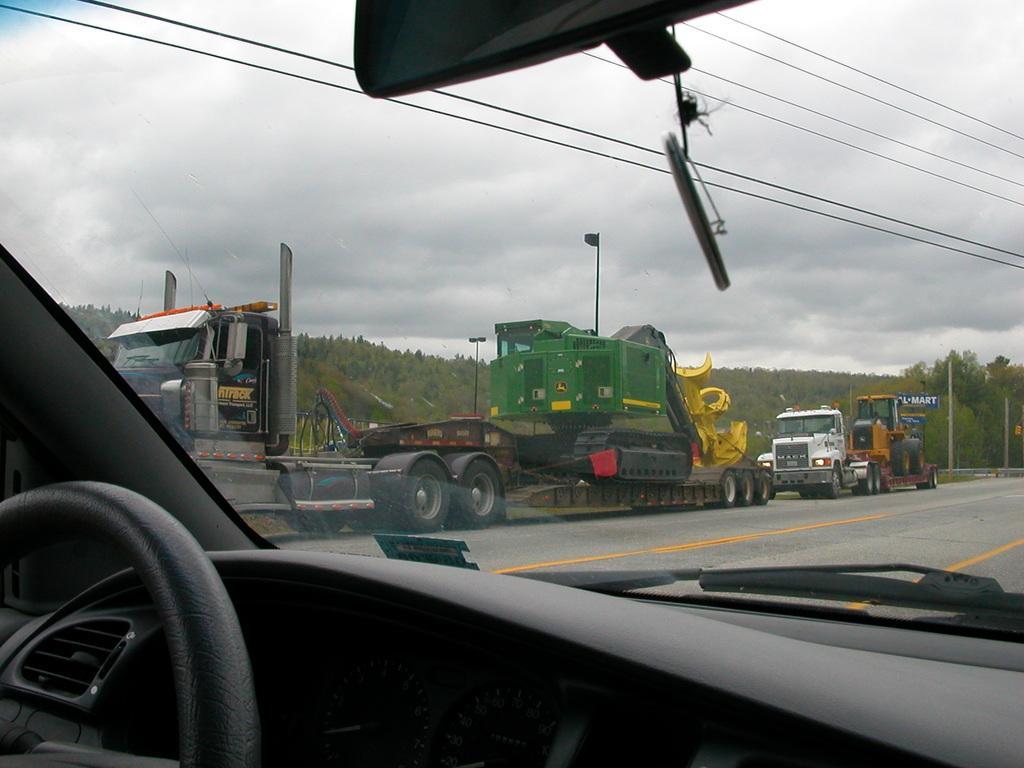Describe this image in one or two sentences. This picture is an inside view of a vehicle. Through glass we can see some vehicles, trees, electric light poles, wires, road, board, clouds are present in the sky. At the bottom left corner we can see steering. At the top of the image we can see a mirror. 